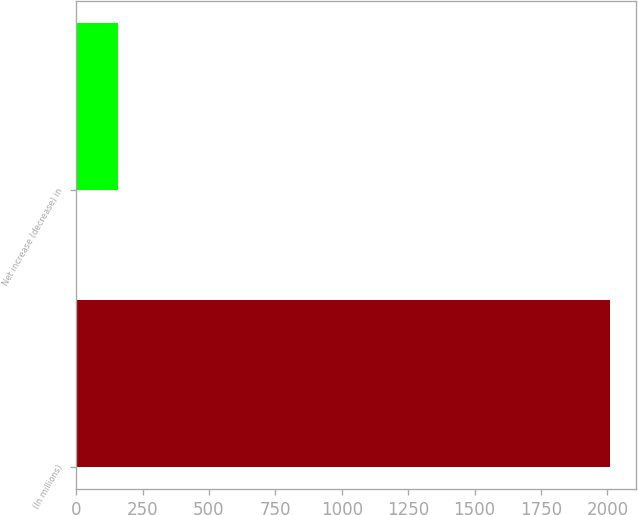<chart> <loc_0><loc_0><loc_500><loc_500><bar_chart><fcel>(In millions)<fcel>Net increase (decrease) in<nl><fcel>2009<fcel>157<nl></chart> 